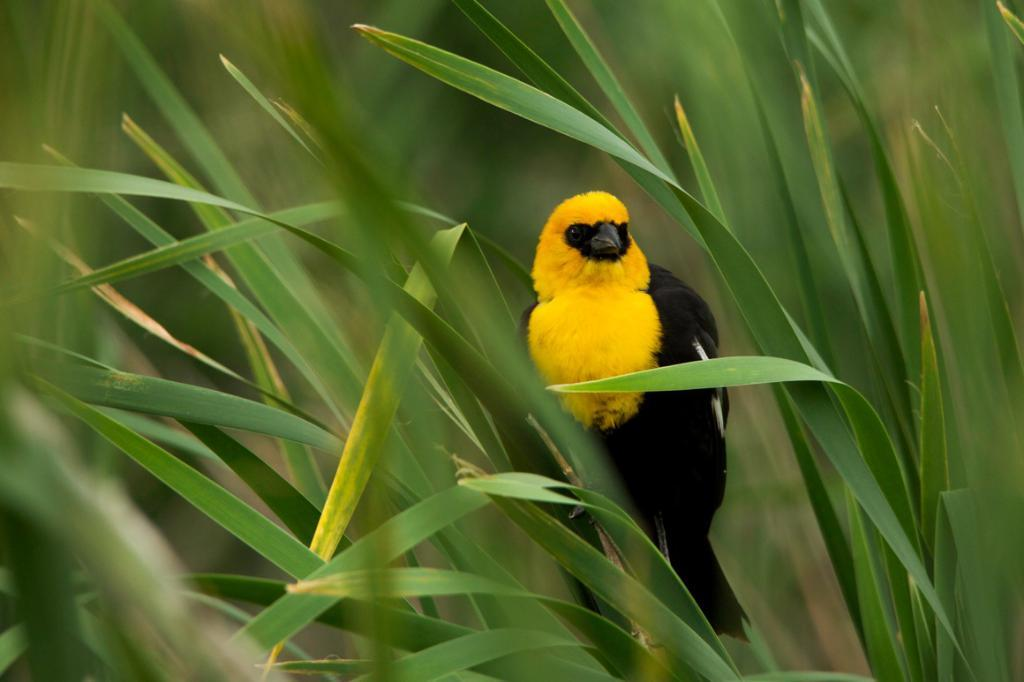What type of living organisms can be seen in the image? Plants can be seen in the image. Is there any animal life present in the image? Yes, there is a bird on one of the plants. Can you describe the background of the image? The background of the image is blurred. What type of payment is required to enter the sky in the image? There is no mention of the sky or any payment in the image; it features plants and a bird. 